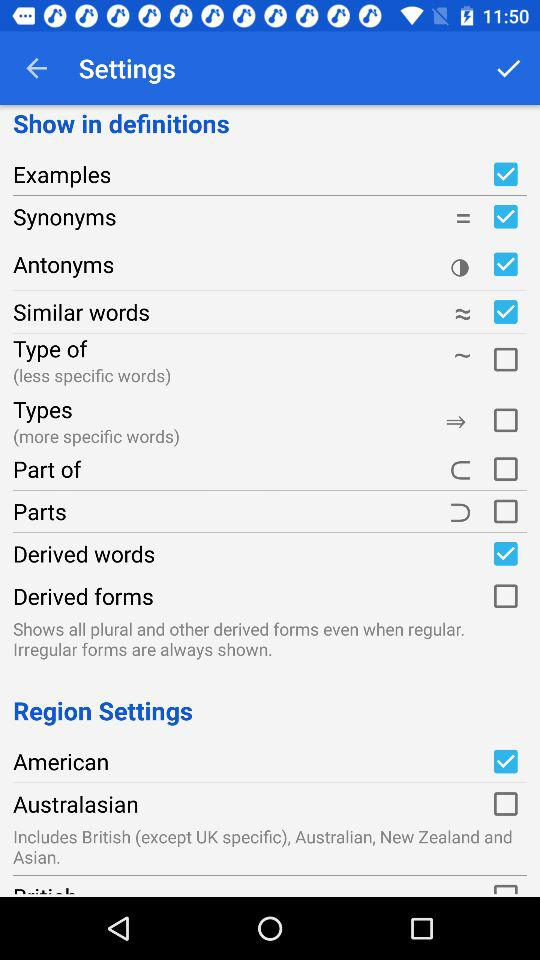Which options are checked? The checked options are "Examples", "Synonyms", "Antonyms", "Similar words", "Derived words" and "American". 